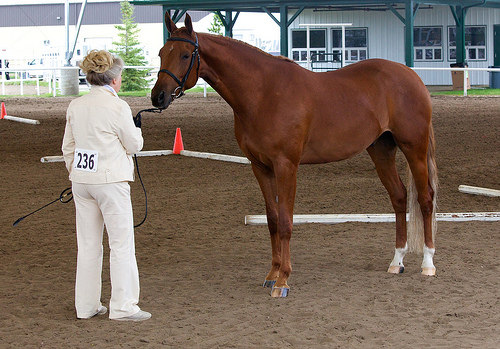<image>
Can you confirm if the lady is on the horse? No. The lady is not positioned on the horse. They may be near each other, but the lady is not supported by or resting on top of the horse. Is there a women to the right of the horse? No. The women is not to the right of the horse. The horizontal positioning shows a different relationship. Is the horse in front of the trainer? Yes. The horse is positioned in front of the trainer, appearing closer to the camera viewpoint. Is there a woman in front of the horse? Yes. The woman is positioned in front of the horse, appearing closer to the camera viewpoint. Is the cone in front of the horse? No. The cone is not in front of the horse. The spatial positioning shows a different relationship between these objects. 